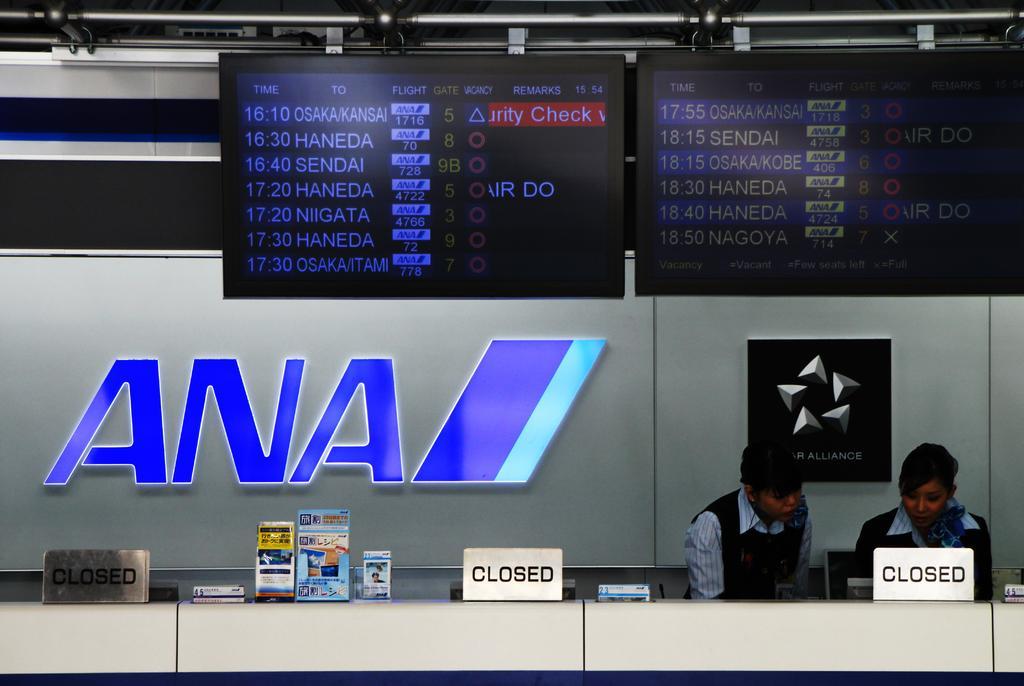In one or two sentences, can you explain what this image depicts? Here in this picture we can see two persons present over there and in front of them we can see a table present and we can see a system present over there and we can see some closed boards present on the table and we can also see other boards present all over there and behind them we can see the logo present on the wall over there and at the top we can see two monitors present over there. 